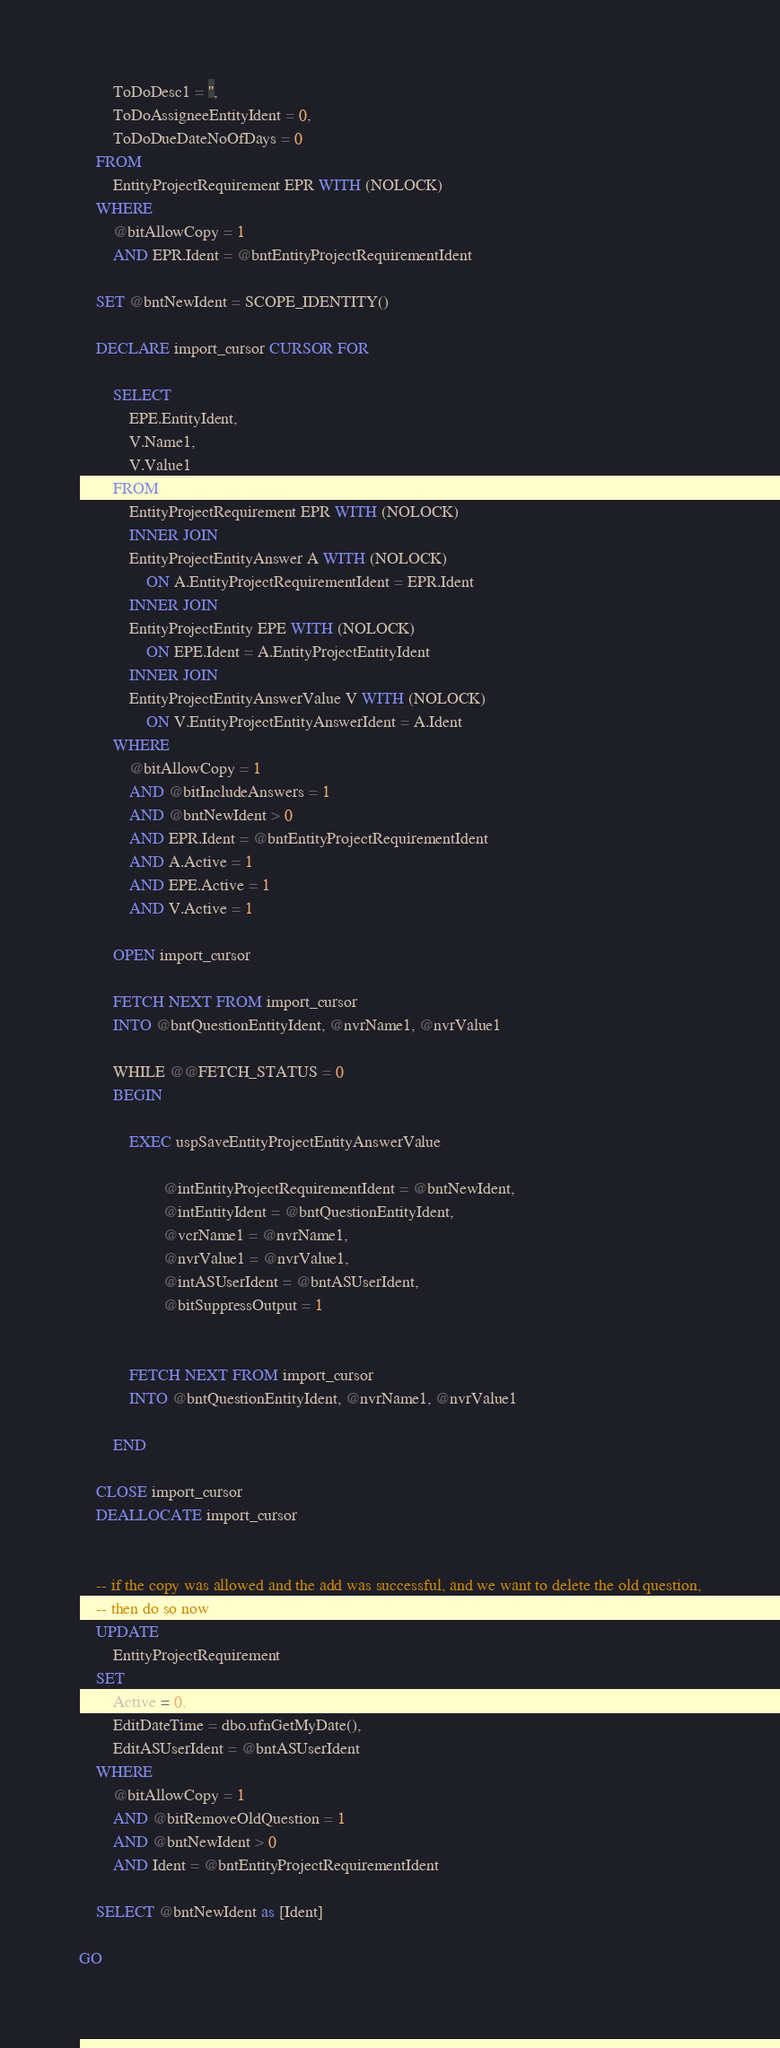<code> <loc_0><loc_0><loc_500><loc_500><_SQL_>		ToDoDesc1 = '',
		ToDoAssigneeEntityIdent = 0,
		ToDoDueDateNoOfDays = 0
	FROM
		EntityProjectRequirement EPR WITH (NOLOCK)
	WHERE
		@bitAllowCopy = 1
		AND EPR.Ident = @bntEntityProjectRequirementIdent

	SET @bntNewIdent = SCOPE_IDENTITY()

	DECLARE import_cursor CURSOR FOR

		SELECT
			EPE.EntityIdent,
			V.Name1,
			V.Value1
		FROM
			EntityProjectRequirement EPR WITH (NOLOCK)
			INNER JOIN
			EntityProjectEntityAnswer A WITH (NOLOCK)
				ON A.EntityProjectRequirementIdent = EPR.Ident
			INNER JOIN
			EntityProjectEntity EPE WITH (NOLOCK)
				ON EPE.Ident = A.EntityProjectEntityIdent
			INNER JOIN
			EntityProjectEntityAnswerValue V WITH (NOLOCK)
				ON V.EntityProjectEntityAnswerIdent = A.Ident
		WHERE
			@bitAllowCopy = 1
			AND @bitIncludeAnswers = 1
			AND @bntNewIdent > 0
			AND EPR.Ident = @bntEntityProjectRequirementIdent
			AND A.Active = 1
			AND EPE.Active = 1
			AND V.Active = 1

		OPEN import_cursor

		FETCH NEXT FROM import_cursor
		INTO @bntQuestionEntityIdent, @nvrName1, @nvrValue1

		WHILE @@FETCH_STATUS = 0
		BEGIN

			EXEC uspSaveEntityProjectEntityAnswerValue

					@intEntityProjectRequirementIdent = @bntNewIdent, 
					@intEntityIdent = @bntQuestionEntityIdent, 
					@vcrName1 = @nvrName1, 
					@nvrValue1 = @nvrValue1,
					@intASUserIdent = @bntASUserIdent,
					@bitSuppressOutput = 1


			FETCH NEXT FROM import_cursor
			INTO @bntQuestionEntityIdent, @nvrName1, @nvrValue1

		END

	CLOSE import_cursor
	DEALLOCATE import_cursor


	-- if the copy was allowed and the add was successful, and we want to delete the old question,
	-- then do so now
	UPDATE
		EntityProjectRequirement
	SET
		Active = 0,
		EditDateTime = dbo.ufnGetMyDate(),
		EditASUserIdent = @bntASUserIdent
	WHERE
		@bitAllowCopy = 1
		AND @bitRemoveOldQuestion = 1
		AND @bntNewIdent > 0
		AND Ident = @bntEntityProjectRequirementIdent

	SELECT @bntNewIdent as [Ident]

GO</code> 